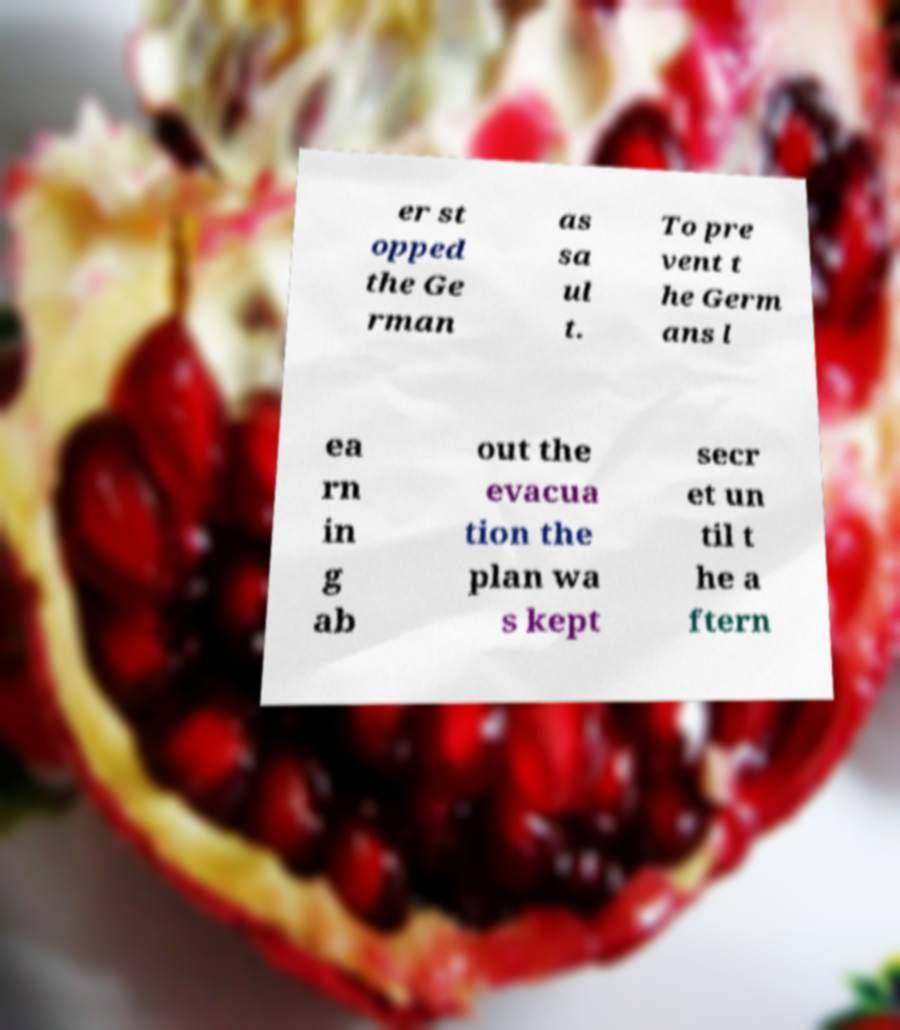Could you assist in decoding the text presented in this image and type it out clearly? er st opped the Ge rman as sa ul t. To pre vent t he Germ ans l ea rn in g ab out the evacua tion the plan wa s kept secr et un til t he a ftern 